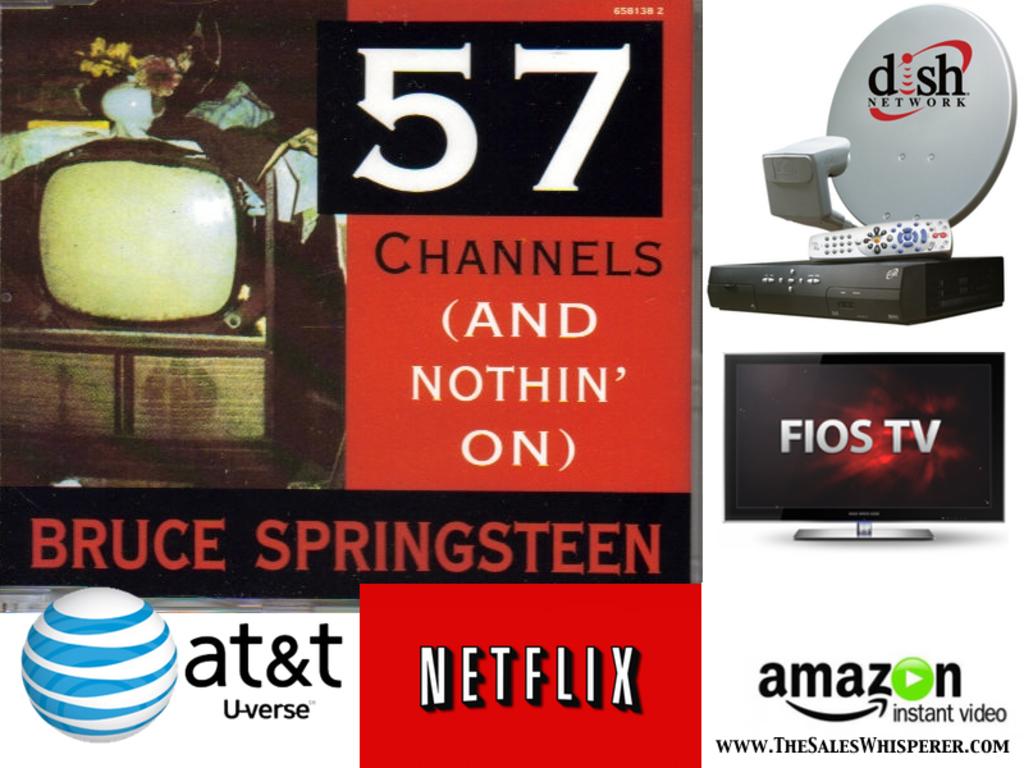What is the big number in white?
Your answer should be compact. 57. Which streaming service in red is mentioned?
Make the answer very short. Netflix. 